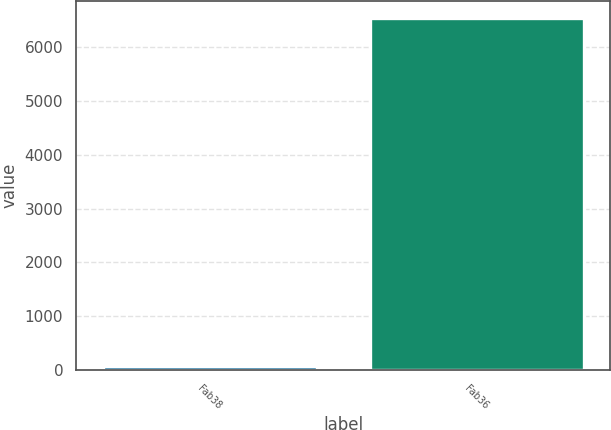Convert chart. <chart><loc_0><loc_0><loc_500><loc_500><bar_chart><fcel>Fab38<fcel>Fab36<nl><fcel>65<fcel>6545<nl></chart> 